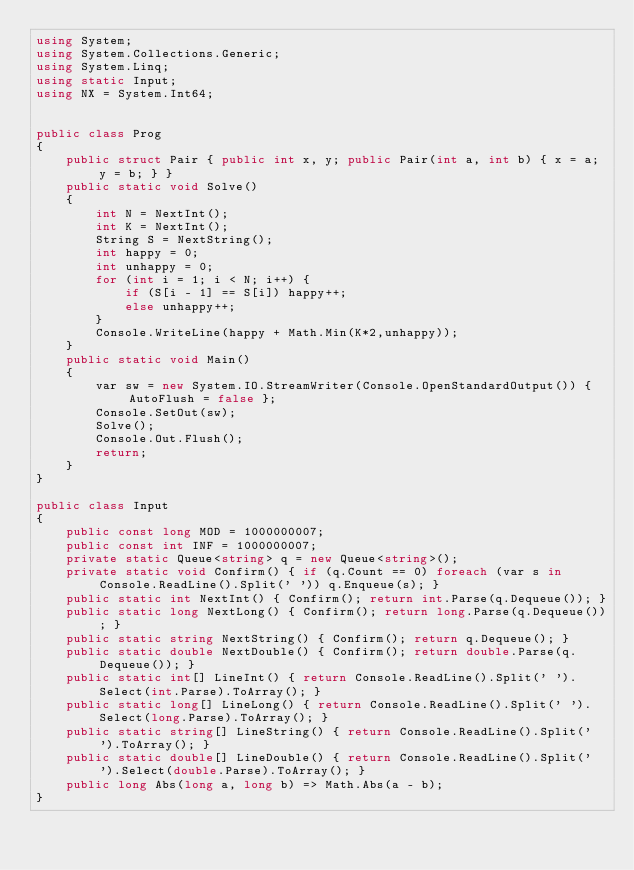<code> <loc_0><loc_0><loc_500><loc_500><_C#_>using System;
using System.Collections.Generic;
using System.Linq;
using static Input;
using NX = System.Int64;


public class Prog
{
    public struct Pair { public int x, y; public Pair(int a, int b) { x = a; y = b; } }
    public static void Solve()
    {
        int N = NextInt();
        int K = NextInt();
        String S = NextString();
        int happy = 0;
        int unhappy = 0;
        for (int i = 1; i < N; i++) {
            if (S[i - 1] == S[i]) happy++;
            else unhappy++;
        }
        Console.WriteLine(happy + Math.Min(K*2,unhappy));
    }
    public static void Main()
    {
        var sw = new System.IO.StreamWriter(Console.OpenStandardOutput()) { AutoFlush = false };
        Console.SetOut(sw);
        Solve();
        Console.Out.Flush();
        return;
    }
}

public class Input
{
    public const long MOD = 1000000007;
    public const int INF = 1000000007;
    private static Queue<string> q = new Queue<string>();
    private static void Confirm() { if (q.Count == 0) foreach (var s in Console.ReadLine().Split(' ')) q.Enqueue(s); }
    public static int NextInt() { Confirm(); return int.Parse(q.Dequeue()); }
    public static long NextLong() { Confirm(); return long.Parse(q.Dequeue()); }
    public static string NextString() { Confirm(); return q.Dequeue(); }
    public static double NextDouble() { Confirm(); return double.Parse(q.Dequeue()); }
    public static int[] LineInt() { return Console.ReadLine().Split(' ').Select(int.Parse).ToArray(); }
    public static long[] LineLong() { return Console.ReadLine().Split(' ').Select(long.Parse).ToArray(); }
    public static string[] LineString() { return Console.ReadLine().Split(' ').ToArray(); }
    public static double[] LineDouble() { return Console.ReadLine().Split(' ').Select(double.Parse).ToArray(); }
    public long Abs(long a, long b) => Math.Abs(a - b);
}
</code> 